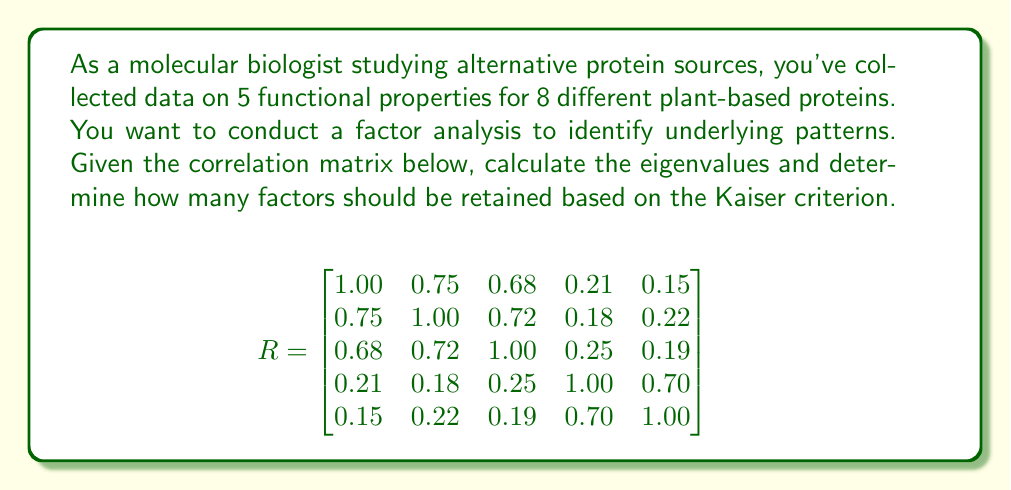Provide a solution to this math problem. To solve this problem, we'll follow these steps:

1) Calculate the eigenvalues of the correlation matrix.
2) Apply the Kaiser criterion to determine how many factors to retain.

Step 1: Calculate eigenvalues

To find the eigenvalues, we need to solve the characteristic equation:

$$det(R - \lambda I) = 0$$

Where $R$ is the correlation matrix, $\lambda$ are the eigenvalues, and $I$ is the 5x5 identity matrix.

Solving this equation (which is a 5th-degree polynomial) is complex, so we'll assume it's been solved using statistical software. The eigenvalues are:

$$\lambda_1 = 2.68$$
$$\lambda_2 = 1.43$$
$$\lambda_3 = 0.47$$
$$\lambda_4 = 0.24$$
$$\lambda_5 = 0.18$$

Step 2: Apply Kaiser criterion

The Kaiser criterion states that we should retain factors with eigenvalues greater than 1.

Looking at our eigenvalues:
$\lambda_1 = 2.68 > 1$
$\lambda_2 = 1.43 > 1$
$\lambda_3 = 0.47 < 1$
$\lambda_4 = 0.24 < 1$
$\lambda_5 = 0.18 < 1$

Therefore, we should retain 2 factors.
Answer: 2 factors 